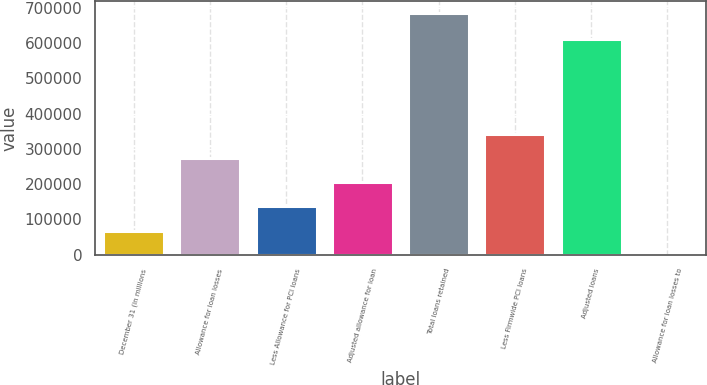Convert chart. <chart><loc_0><loc_0><loc_500><loc_500><bar_chart><fcel>December 31 (in millions<fcel>Allowance for loan losses<fcel>Less Allowance for PCI loans<fcel>Adjusted allowance for loan<fcel>Total loans retained<fcel>Less Firmwide PCI loans<fcel>Adjusted loans<fcel>Allowance for loan losses to<nl><fcel>68553.8<fcel>274202<fcel>137103<fcel>205653<fcel>685498<fcel>342751<fcel>612691<fcel>4.46<nl></chart> 